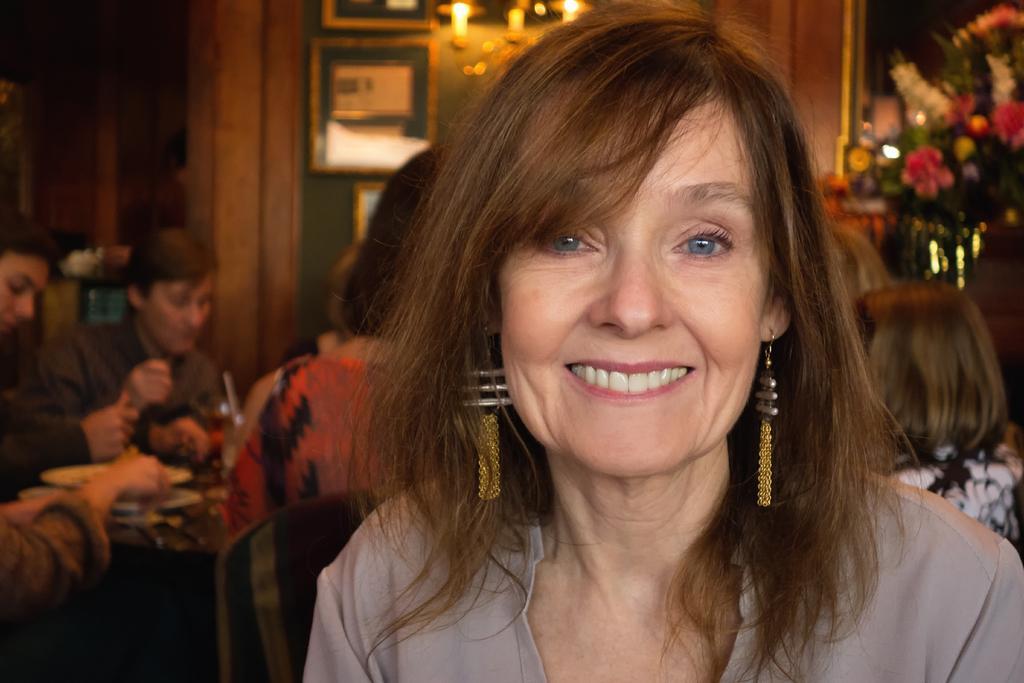Could you give a brief overview of what you see in this image? In this image in front there is a person wearing a smile on her face. Behind her there are a few other people sitting on the chairs. There is a table. On top of it there are a few objects. In the background of the image there are photo frames on the wall. There are lights. On the right side of the image there is a bouquet. 